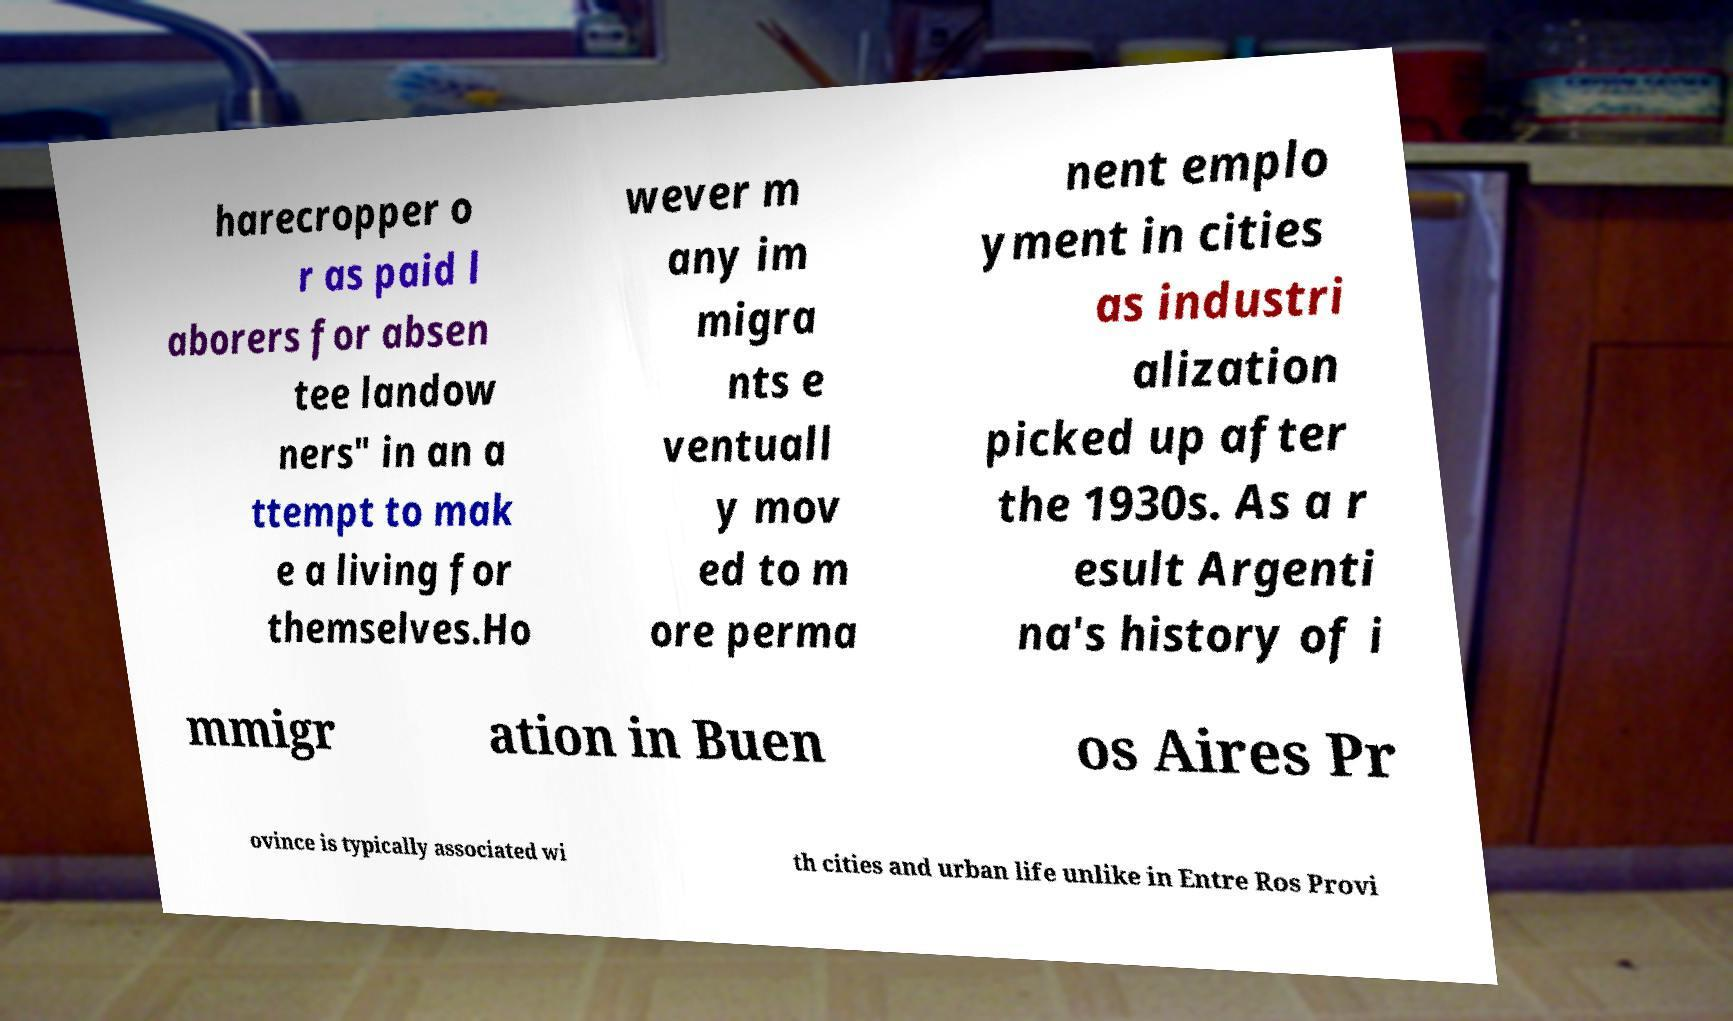There's text embedded in this image that I need extracted. Can you transcribe it verbatim? harecropper o r as paid l aborers for absen tee landow ners" in an a ttempt to mak e a living for themselves.Ho wever m any im migra nts e ventuall y mov ed to m ore perma nent emplo yment in cities as industri alization picked up after the 1930s. As a r esult Argenti na's history of i mmigr ation in Buen os Aires Pr ovince is typically associated wi th cities and urban life unlike in Entre Ros Provi 